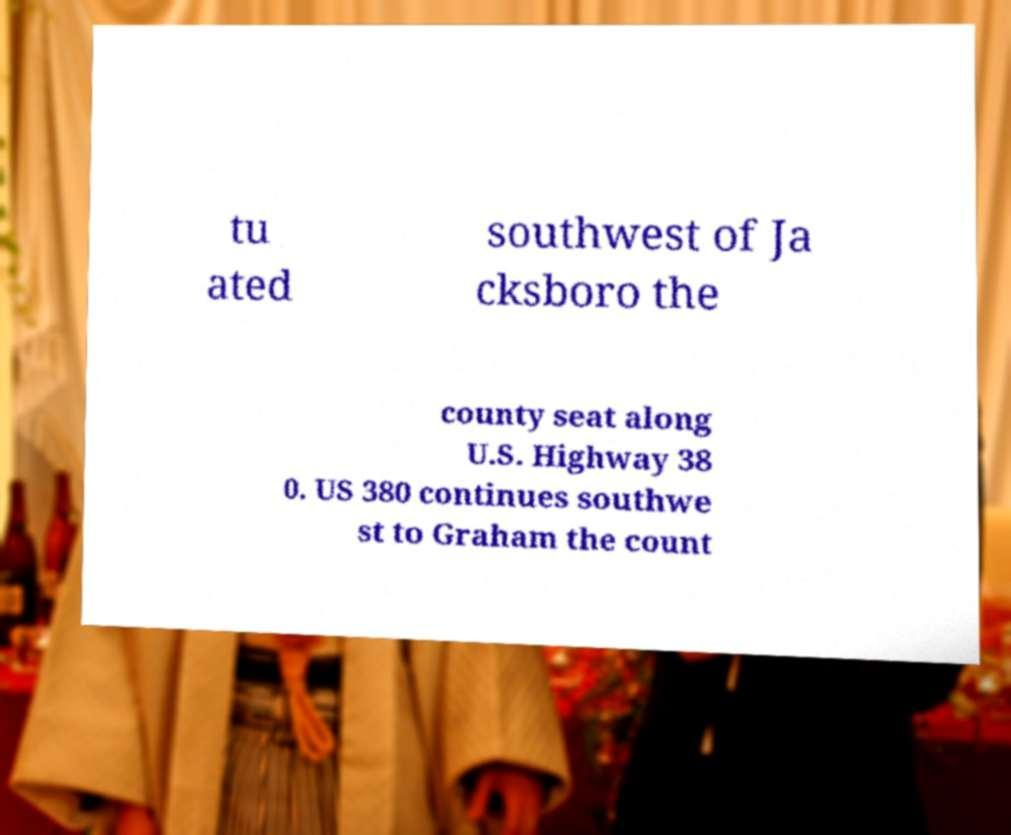I need the written content from this picture converted into text. Can you do that? tu ated southwest of Ja cksboro the county seat along U.S. Highway 38 0. US 380 continues southwe st to Graham the count 